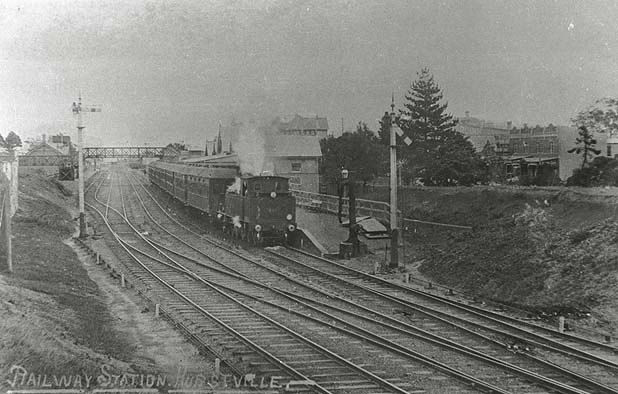<image>Why are there many railroads on the ground? It is unknown why there are many railroads on the ground. However, it could be a train yard or station, and it allows multiple trains to operate in different directions. Why are there many railroads on the ground? I don't know why there are many railroads on the ground. It could be because different railroad lines converge there, so trains can go in different directions. It could also be because it is a train yard where many trains can run. 